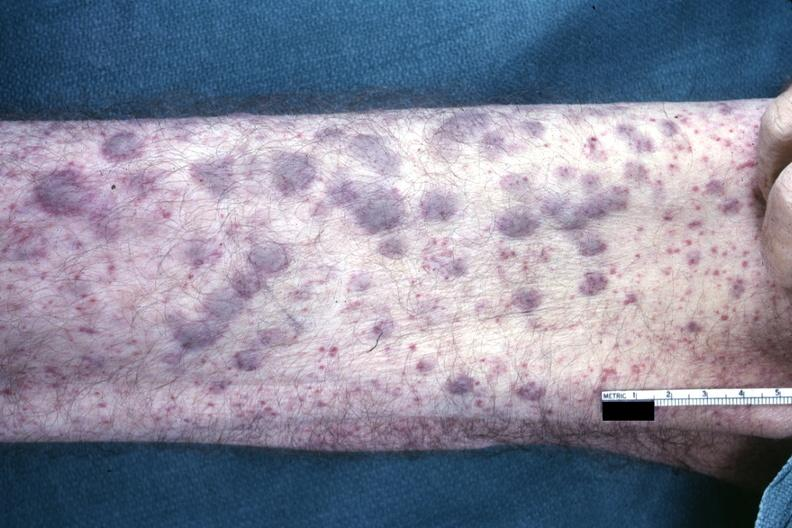what is not good color photo showing elevated macular lesions said?
Answer the question using a single word or phrase. To be infiltrates of aml 